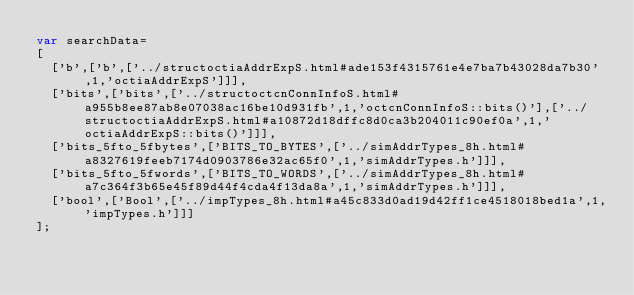<code> <loc_0><loc_0><loc_500><loc_500><_JavaScript_>var searchData=
[
  ['b',['b',['../structoctiaAddrExpS.html#ade153f4315761e4e7ba7b43028da7b30',1,'octiaAddrExpS']]],
  ['bits',['bits',['../structoctcnConnInfoS.html#a955b8ee87ab8e07038ac16be10d931fb',1,'octcnConnInfoS::bits()'],['../structoctiaAddrExpS.html#a10872d18dffc8d0ca3b204011c90ef0a',1,'octiaAddrExpS::bits()']]],
  ['bits_5fto_5fbytes',['BITS_TO_BYTES',['../simAddrTypes_8h.html#a8327619feeb7174d0903786e32ac65f0',1,'simAddrTypes.h']]],
  ['bits_5fto_5fwords',['BITS_TO_WORDS',['../simAddrTypes_8h.html#a7c364f3b65e45f89d44f4cda4f13da8a',1,'simAddrTypes.h']]],
  ['bool',['Bool',['../impTypes_8h.html#a45c833d0ad19d42ff1ce4518018bed1a',1,'impTypes.h']]]
];
</code> 